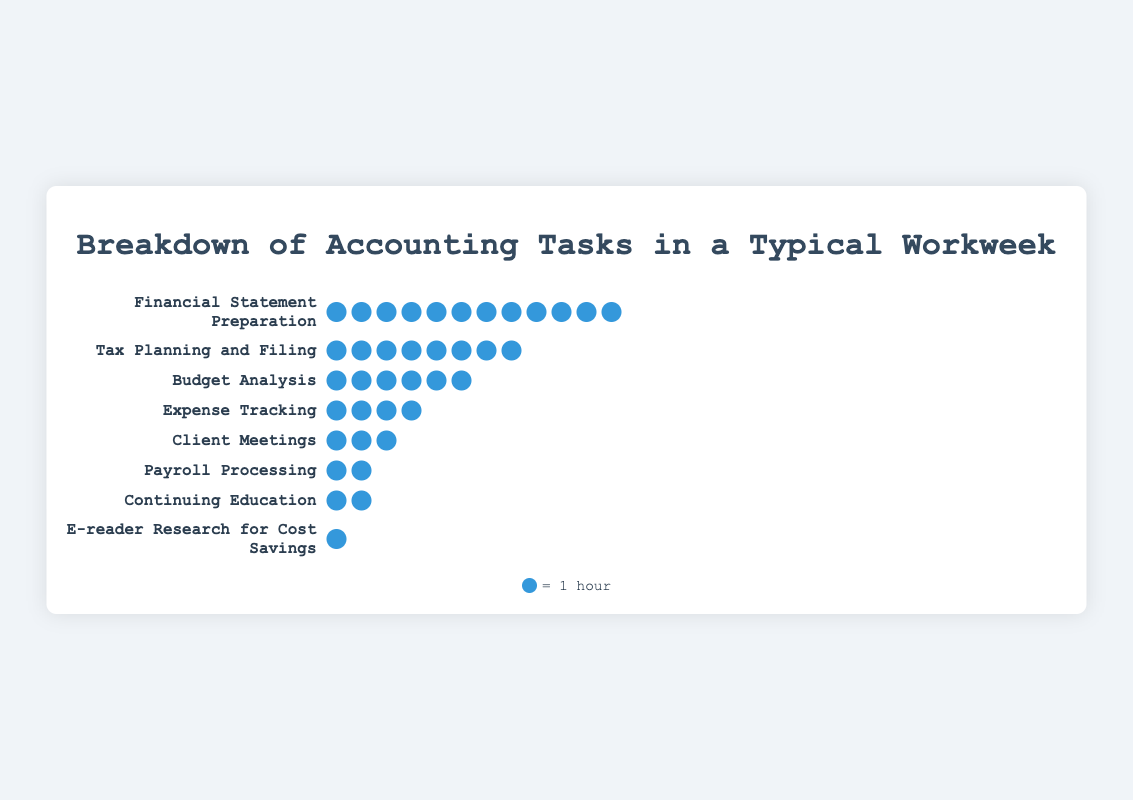Which accounting task is allocated the most hours? By visually inspecting the rows, we can see that "Financial Statement Preparation" has the most icons (12), indicating the highest allocation of hours.
Answer: Financial Statement Preparation Which accounting tasks are given the least amount of time? By observing the rows with the least number of icons, "E-reader Research for Cost Savings" is allocated only one icon (1 hour).
Answer: E-reader Research for Cost Savings How many total hours are spent on tasks that take 4 hours or more? Adding hours for tasks: Financial Statement Preparation (12), Tax Planning and Filing (8), Budget Analysis (6), and Expense Tracking (4). 12 + 8 + 6 + 4 = 30 hours.
Answer: 30 hours How many hours are spent on tasks related to education and research? Viewing the individual icons for “Continuing Education” (2) and “E-reader Research for Cost Savings” (1). 2 + 1 = 3 hours.
Answer: 3 hours Is more time spent on Client Meetings or Payroll Processing? Comparing the rows, Client Meetings has 3 icons and Payroll Processing has 2 icons. Therefore, more time is spent on Client Meetings.
Answer: Client Meetings How many tasks require more than 5 hours each? Tasks with more than 5 icons are: Financial Statement Preparation (12), Tax Planning and Filing (8), and Budget Analysis (6). Total = 3 tasks.
Answer: 3 tasks How does the time spent on Budget Analysis compare to the time spent on Client Meetings? Budget Analysis has 6 icons, while Client Meetings has 3 icons. Thus, time spent on Budget Analysis is more.
Answer: Budget Analysis What is the total number of hours represented in the isotype plot? Summing all hours: 12 (Financial) + 8 (Tax) + 6 (Budget) + 4 (Expense) + 3 (Client) + 2 (Payroll) + 2 (Education) + 1 (E-reader). 12 + 8 + 6 + 4 + 3 + 2 + 2 + 1 = 38 hours.
Answer: 38 hours Which has a higher combined total of hours: Expense Tracking and Payroll Processing or Tax Planning and Filing? Summing hours: Expense Tracking (4) + Payroll Processing (2) = 6, and Tax Planning and Filing = 8. Thus, Tax Planning and Filing has a higher combined total.
Answer: Tax Planning and Filing 